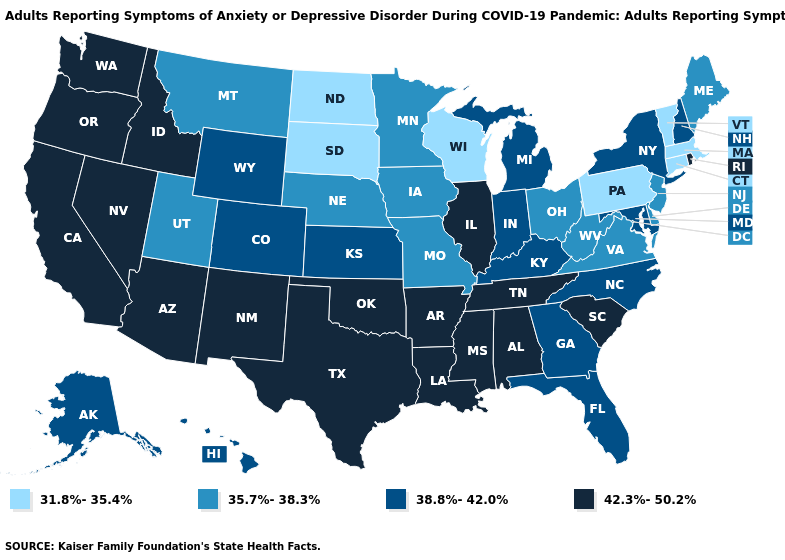Does the map have missing data?
Be succinct. No. Which states have the lowest value in the USA?
Be succinct. Connecticut, Massachusetts, North Dakota, Pennsylvania, South Dakota, Vermont, Wisconsin. Name the states that have a value in the range 38.8%-42.0%?
Answer briefly. Alaska, Colorado, Florida, Georgia, Hawaii, Indiana, Kansas, Kentucky, Maryland, Michigan, New Hampshire, New York, North Carolina, Wyoming. Among the states that border North Dakota , which have the highest value?
Quick response, please. Minnesota, Montana. Which states hav the highest value in the Northeast?
Give a very brief answer. Rhode Island. Which states have the lowest value in the USA?
Concise answer only. Connecticut, Massachusetts, North Dakota, Pennsylvania, South Dakota, Vermont, Wisconsin. What is the value of Ohio?
Keep it brief. 35.7%-38.3%. Is the legend a continuous bar?
Short answer required. No. What is the value of Massachusetts?
Give a very brief answer. 31.8%-35.4%. What is the value of Virginia?
Give a very brief answer. 35.7%-38.3%. Name the states that have a value in the range 31.8%-35.4%?
Write a very short answer. Connecticut, Massachusetts, North Dakota, Pennsylvania, South Dakota, Vermont, Wisconsin. What is the highest value in the West ?
Give a very brief answer. 42.3%-50.2%. Which states have the lowest value in the USA?
Write a very short answer. Connecticut, Massachusetts, North Dakota, Pennsylvania, South Dakota, Vermont, Wisconsin. How many symbols are there in the legend?
Keep it brief. 4. 